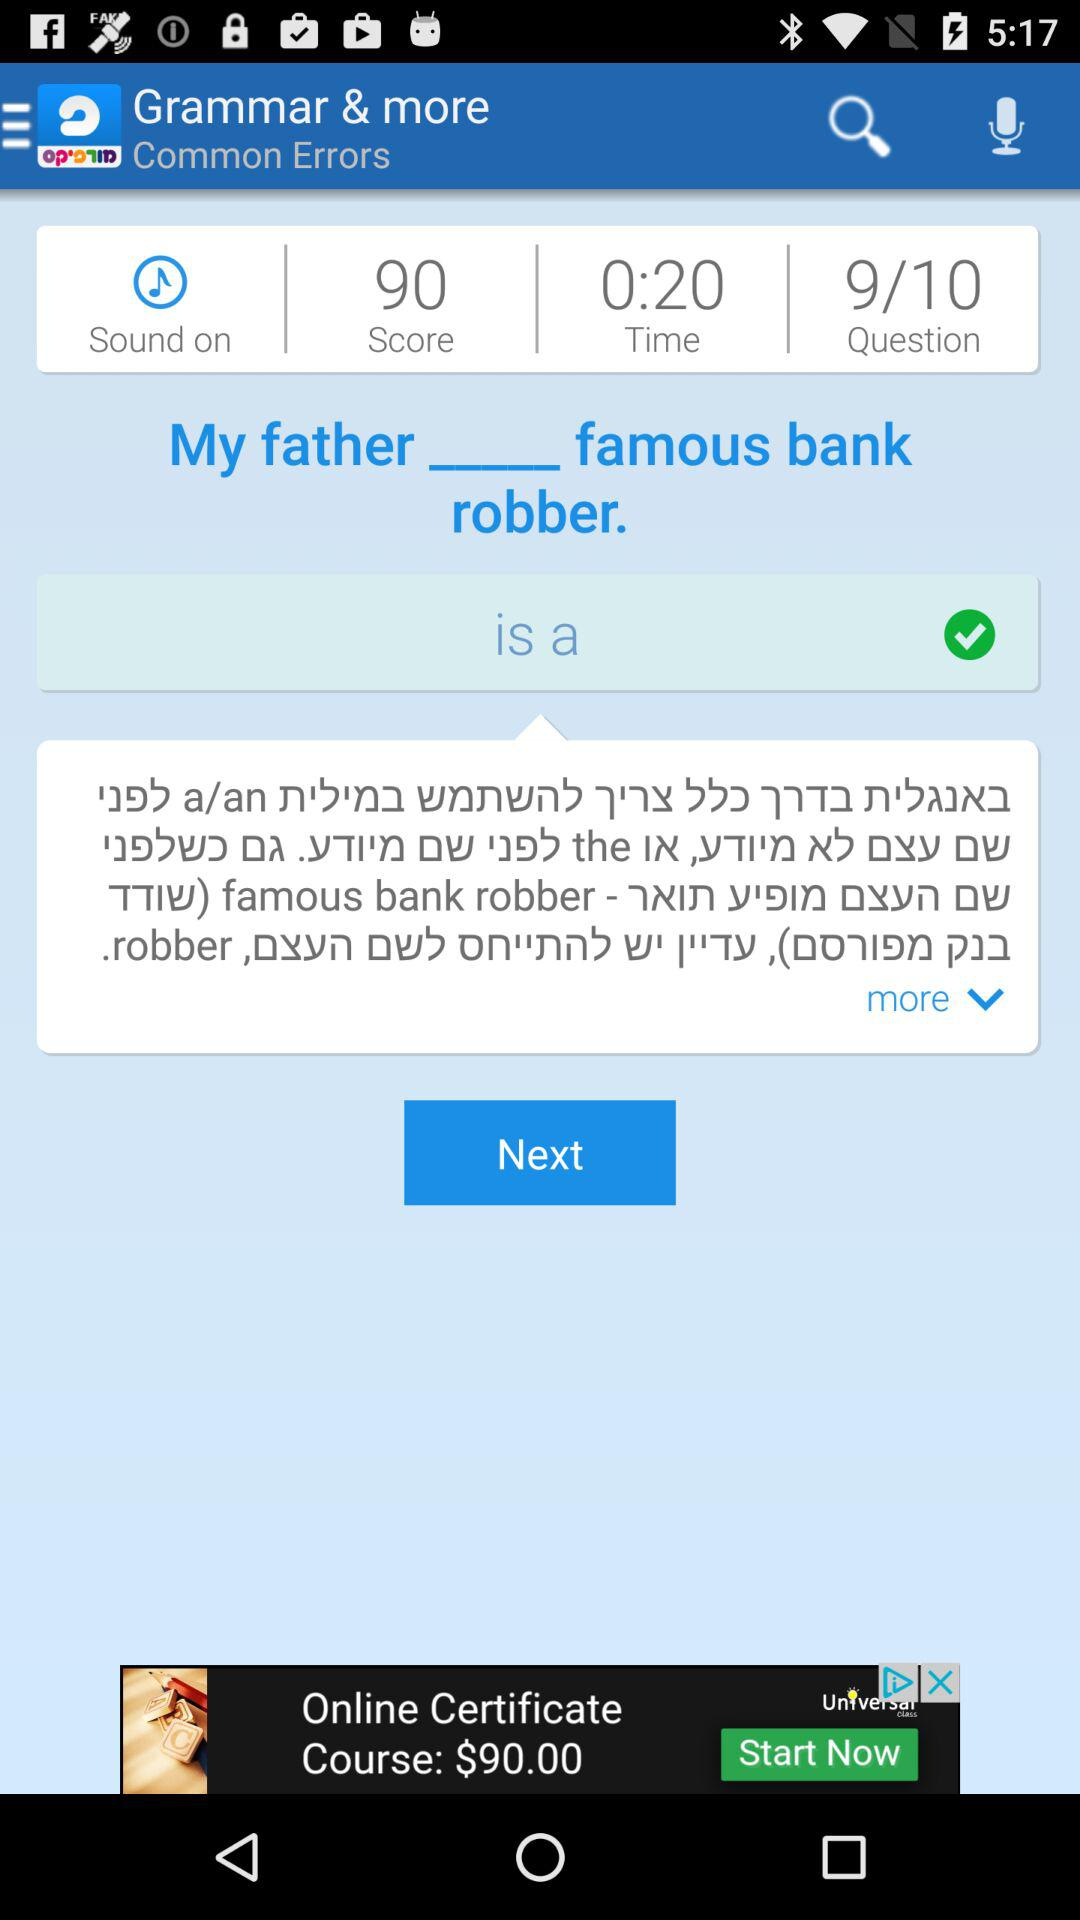How many questions are there? There are 10 questions. 